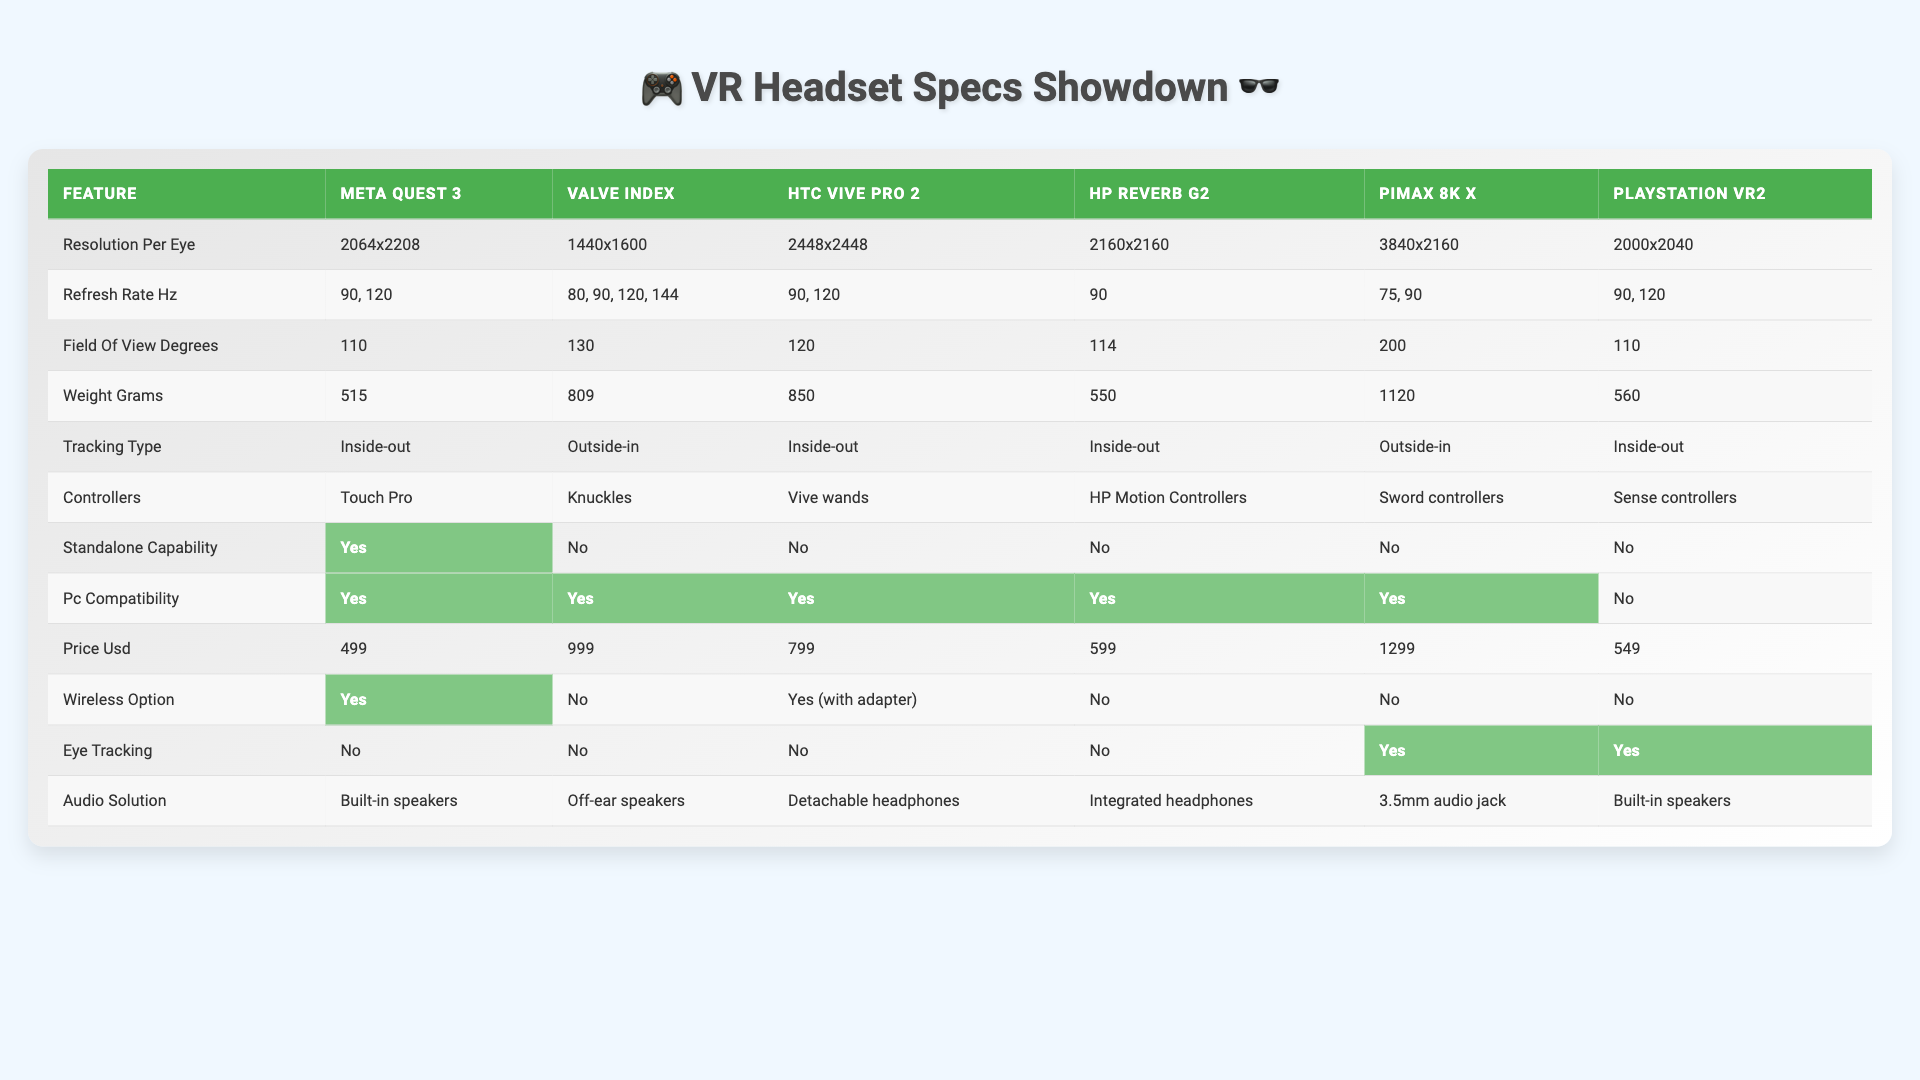What is the resolution per eye of the HTC Vive Pro 2? The HTC Vive Pro 2 has a resolution per eye listed as 2448x2448 in the table.
Answer: 2448x2448 Which headset has the highest refresh rate option? The Valve Index has multiple refresh rate options listed, namely 80, 90, 120, and 144 Hz, making it the headset with the highest refresh rate capability.
Answer: Valve Index Is the Meta Quest 3 standalone? The table indicates that the Meta Quest 3 has "Yes" listed under Standalone Capability, signifying that it is a standalone headset.
Answer: Yes How does the weight of the Pimax 8K X compare to the HP Reverb G2? The weight of the Pimax 8K X is 1120 grams, while the HP Reverb G2 weighs 550 grams. The difference in weight is 1120 - 550 = 570 grams, making the Pimax 8K X significantly heavier.
Answer: Pimax 8K X is 570 grams heavier What is the average field of view for the headsets listed? To find the average field of view, sum the FOV values: 110 + 130 + 120 + 114 + 200 + 110 = 784. There are 6 headsets, so the average FOV is 784 / 6 = 130.67 degrees.
Answer: 130.67 degrees Which headset offers eye tracking capability? According to the table, eye tracking is available in the Pimax 8K X and PlayStation VR2, as they both have "Yes" under Eye Tracking.
Answer: Pimax 8K X and PlayStation VR2 How many headsets have built-in speakers for audio? The table shows that the Meta Quest 3 and PlayStation VR2 both have "Built-in speakers" listed under Audio Solution, indicating that 2 headsets offer this feature.
Answer: 2 headsets Is the HP Reverb G2 compatible with PC? The table indicates that the HP Reverb G2 has "Yes" listed under PC Compatibility, therefore it is compatible with PC.
Answer: Yes Which headset has the widest field of view and what is it? The Pimax 8K X has the widest field of view listed as 200 degrees, according to the table.
Answer: 200 degrees What is the total price of the Meta Quest 3 and PlayStation VR2? The price of the Meta Quest 3 is 499 USD and the price of the PlayStation VR2 is 549 USD. Summing them gives 499 + 549 = 1048 USD.
Answer: 1048 USD Which headset has the lowest weight, and what is that weight? The HP Reverb G2 weighs 550 grams, which is the lowest weight listed in the table compared to the other headsets.
Answer: 550 grams 